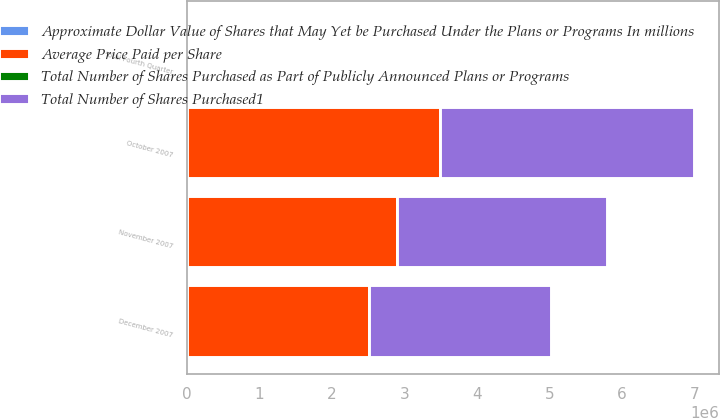Convert chart to OTSL. <chart><loc_0><loc_0><loc_500><loc_500><stacked_bar_chart><ecel><fcel>October 2007<fcel>November 2007<fcel>December 2007<fcel>Total Fourth Quarter<nl><fcel>Average Price Paid per Share<fcel>3.49343e+06<fcel>2.89172e+06<fcel>2.51042e+06<fcel>386.05<nl><fcel>Total Number of Shares Purchased as Part of Publicly Announced Plans or Programs<fcel>43.3<fcel>44.16<fcel>44.2<fcel>43.27<nl><fcel>Total Number of Shares Purchased1<fcel>3.49343e+06<fcel>2.89172e+06<fcel>2.51042e+06<fcel>386.05<nl><fcel>Approximate Dollar Value of Shares that May Yet be Purchased Under the Plans or Programs In millions<fcel>449.9<fcel>322.2<fcel>216.2<fcel>216.2<nl></chart> 